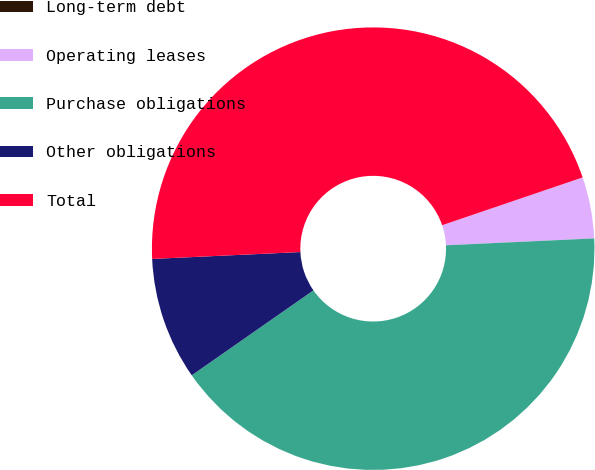<chart> <loc_0><loc_0><loc_500><loc_500><pie_chart><fcel>Long-term debt<fcel>Operating leases<fcel>Purchase obligations<fcel>Other obligations<fcel>Total<nl><fcel>0.0%<fcel>4.48%<fcel>41.04%<fcel>8.96%<fcel>45.52%<nl></chart> 